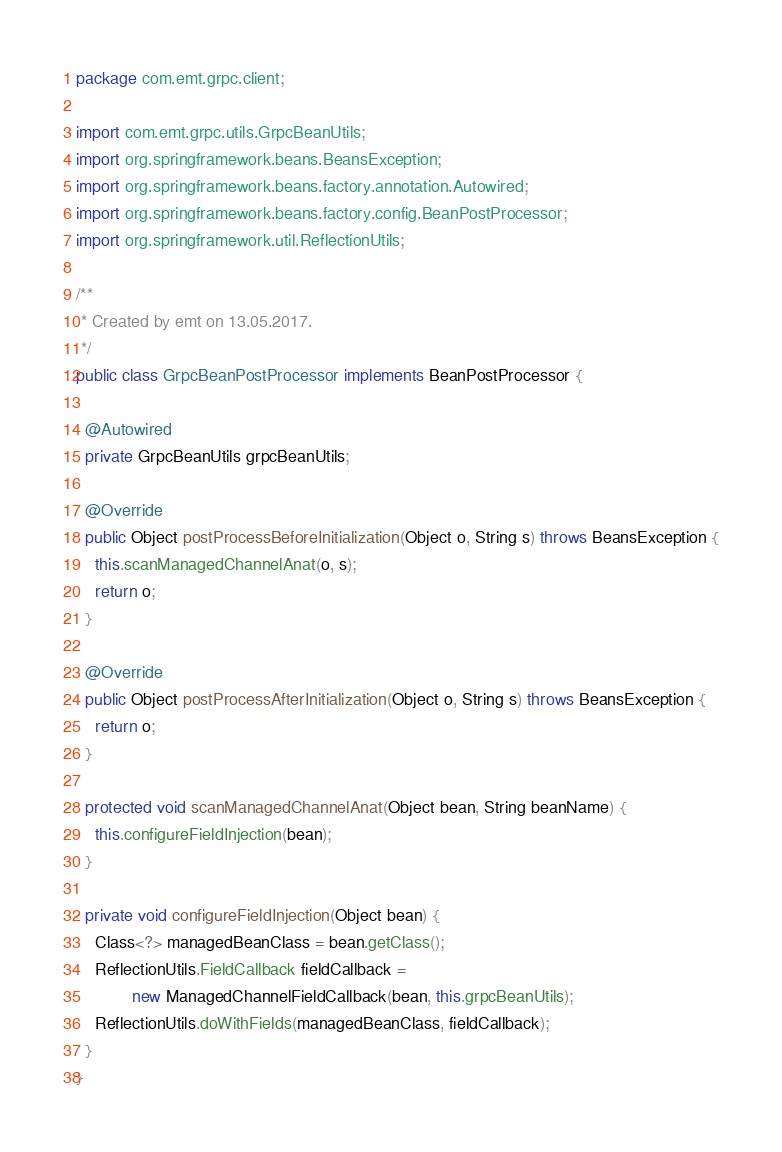<code> <loc_0><loc_0><loc_500><loc_500><_Java_>package com.emt.grpc.client;

import com.emt.grpc.utils.GrpcBeanUtils;
import org.springframework.beans.BeansException;
import org.springframework.beans.factory.annotation.Autowired;
import org.springframework.beans.factory.config.BeanPostProcessor;
import org.springframework.util.ReflectionUtils;

/**
 * Created by emt on 13.05.2017.
 */
public class GrpcBeanPostProcessor implements BeanPostProcessor {

  @Autowired
  private GrpcBeanUtils grpcBeanUtils;

  @Override
  public Object postProcessBeforeInitialization(Object o, String s) throws BeansException {
    this.scanManagedChannelAnat(o, s);
    return o;
  }

  @Override
  public Object postProcessAfterInitialization(Object o, String s) throws BeansException {
    return o;
  }

  protected void scanManagedChannelAnat(Object bean, String beanName) {
    this.configureFieldInjection(bean);
  }

  private void configureFieldInjection(Object bean) {
    Class<?> managedBeanClass = bean.getClass();
    ReflectionUtils.FieldCallback fieldCallback =
            new ManagedChannelFieldCallback(bean, this.grpcBeanUtils);
    ReflectionUtils.doWithFields(managedBeanClass, fieldCallback);
  }
}
</code> 